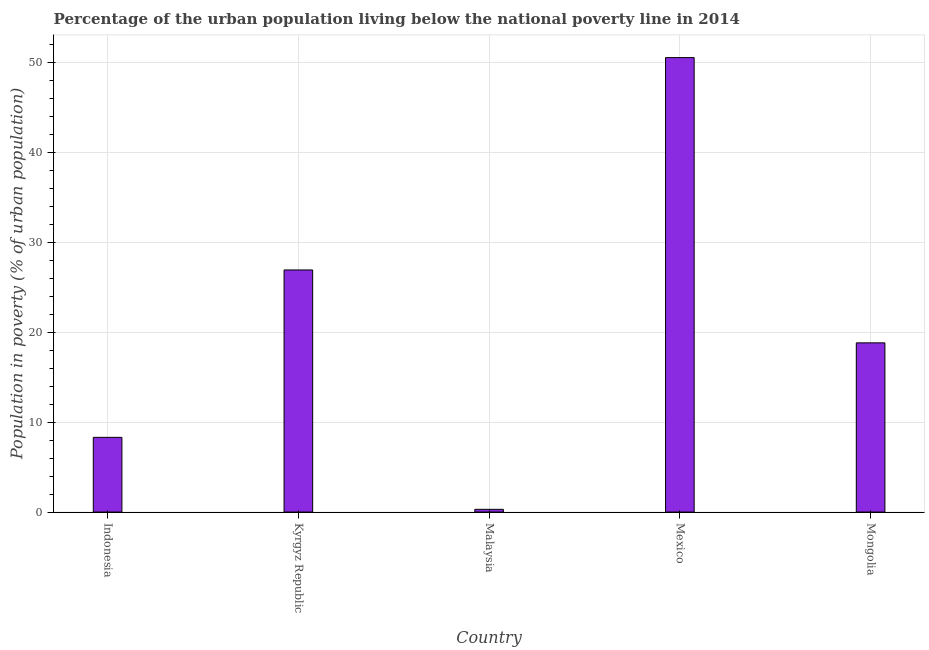Does the graph contain any zero values?
Ensure brevity in your answer.  No. Does the graph contain grids?
Provide a short and direct response. Yes. What is the title of the graph?
Provide a succinct answer. Percentage of the urban population living below the national poverty line in 2014. What is the label or title of the X-axis?
Provide a short and direct response. Country. What is the label or title of the Y-axis?
Make the answer very short. Population in poverty (% of urban population). What is the percentage of urban population living below poverty line in Mexico?
Give a very brief answer. 50.5. Across all countries, what is the maximum percentage of urban population living below poverty line?
Provide a succinct answer. 50.5. Across all countries, what is the minimum percentage of urban population living below poverty line?
Your response must be concise. 0.3. In which country was the percentage of urban population living below poverty line maximum?
Provide a succinct answer. Mexico. In which country was the percentage of urban population living below poverty line minimum?
Make the answer very short. Malaysia. What is the sum of the percentage of urban population living below poverty line?
Offer a very short reply. 104.8. What is the difference between the percentage of urban population living below poverty line in Indonesia and Mongolia?
Your response must be concise. -10.5. What is the average percentage of urban population living below poverty line per country?
Offer a terse response. 20.96. What is the ratio of the percentage of urban population living below poverty line in Kyrgyz Republic to that in Mongolia?
Offer a very short reply. 1.43. Is the percentage of urban population living below poverty line in Mexico less than that in Mongolia?
Provide a succinct answer. No. What is the difference between the highest and the second highest percentage of urban population living below poverty line?
Your answer should be very brief. 23.6. Is the sum of the percentage of urban population living below poverty line in Indonesia and Mongolia greater than the maximum percentage of urban population living below poverty line across all countries?
Ensure brevity in your answer.  No. What is the difference between the highest and the lowest percentage of urban population living below poverty line?
Ensure brevity in your answer.  50.2. In how many countries, is the percentage of urban population living below poverty line greater than the average percentage of urban population living below poverty line taken over all countries?
Your answer should be very brief. 2. How many bars are there?
Ensure brevity in your answer.  5. How many countries are there in the graph?
Provide a succinct answer. 5. What is the difference between two consecutive major ticks on the Y-axis?
Make the answer very short. 10. Are the values on the major ticks of Y-axis written in scientific E-notation?
Offer a very short reply. No. What is the Population in poverty (% of urban population) in Indonesia?
Your answer should be compact. 8.3. What is the Population in poverty (% of urban population) of Kyrgyz Republic?
Your answer should be compact. 26.9. What is the Population in poverty (% of urban population) of Mexico?
Provide a succinct answer. 50.5. What is the Population in poverty (% of urban population) in Mongolia?
Keep it short and to the point. 18.8. What is the difference between the Population in poverty (% of urban population) in Indonesia and Kyrgyz Republic?
Your answer should be compact. -18.6. What is the difference between the Population in poverty (% of urban population) in Indonesia and Mexico?
Offer a terse response. -42.2. What is the difference between the Population in poverty (% of urban population) in Kyrgyz Republic and Malaysia?
Provide a succinct answer. 26.6. What is the difference between the Population in poverty (% of urban population) in Kyrgyz Republic and Mexico?
Provide a succinct answer. -23.6. What is the difference between the Population in poverty (% of urban population) in Kyrgyz Republic and Mongolia?
Give a very brief answer. 8.1. What is the difference between the Population in poverty (% of urban population) in Malaysia and Mexico?
Give a very brief answer. -50.2. What is the difference between the Population in poverty (% of urban population) in Malaysia and Mongolia?
Your response must be concise. -18.5. What is the difference between the Population in poverty (% of urban population) in Mexico and Mongolia?
Your answer should be compact. 31.7. What is the ratio of the Population in poverty (% of urban population) in Indonesia to that in Kyrgyz Republic?
Keep it short and to the point. 0.31. What is the ratio of the Population in poverty (% of urban population) in Indonesia to that in Malaysia?
Your answer should be very brief. 27.67. What is the ratio of the Population in poverty (% of urban population) in Indonesia to that in Mexico?
Make the answer very short. 0.16. What is the ratio of the Population in poverty (% of urban population) in Indonesia to that in Mongolia?
Your answer should be compact. 0.44. What is the ratio of the Population in poverty (% of urban population) in Kyrgyz Republic to that in Malaysia?
Provide a succinct answer. 89.67. What is the ratio of the Population in poverty (% of urban population) in Kyrgyz Republic to that in Mexico?
Offer a very short reply. 0.53. What is the ratio of the Population in poverty (% of urban population) in Kyrgyz Republic to that in Mongolia?
Provide a short and direct response. 1.43. What is the ratio of the Population in poverty (% of urban population) in Malaysia to that in Mexico?
Your answer should be very brief. 0.01. What is the ratio of the Population in poverty (% of urban population) in Malaysia to that in Mongolia?
Provide a succinct answer. 0.02. What is the ratio of the Population in poverty (% of urban population) in Mexico to that in Mongolia?
Keep it short and to the point. 2.69. 